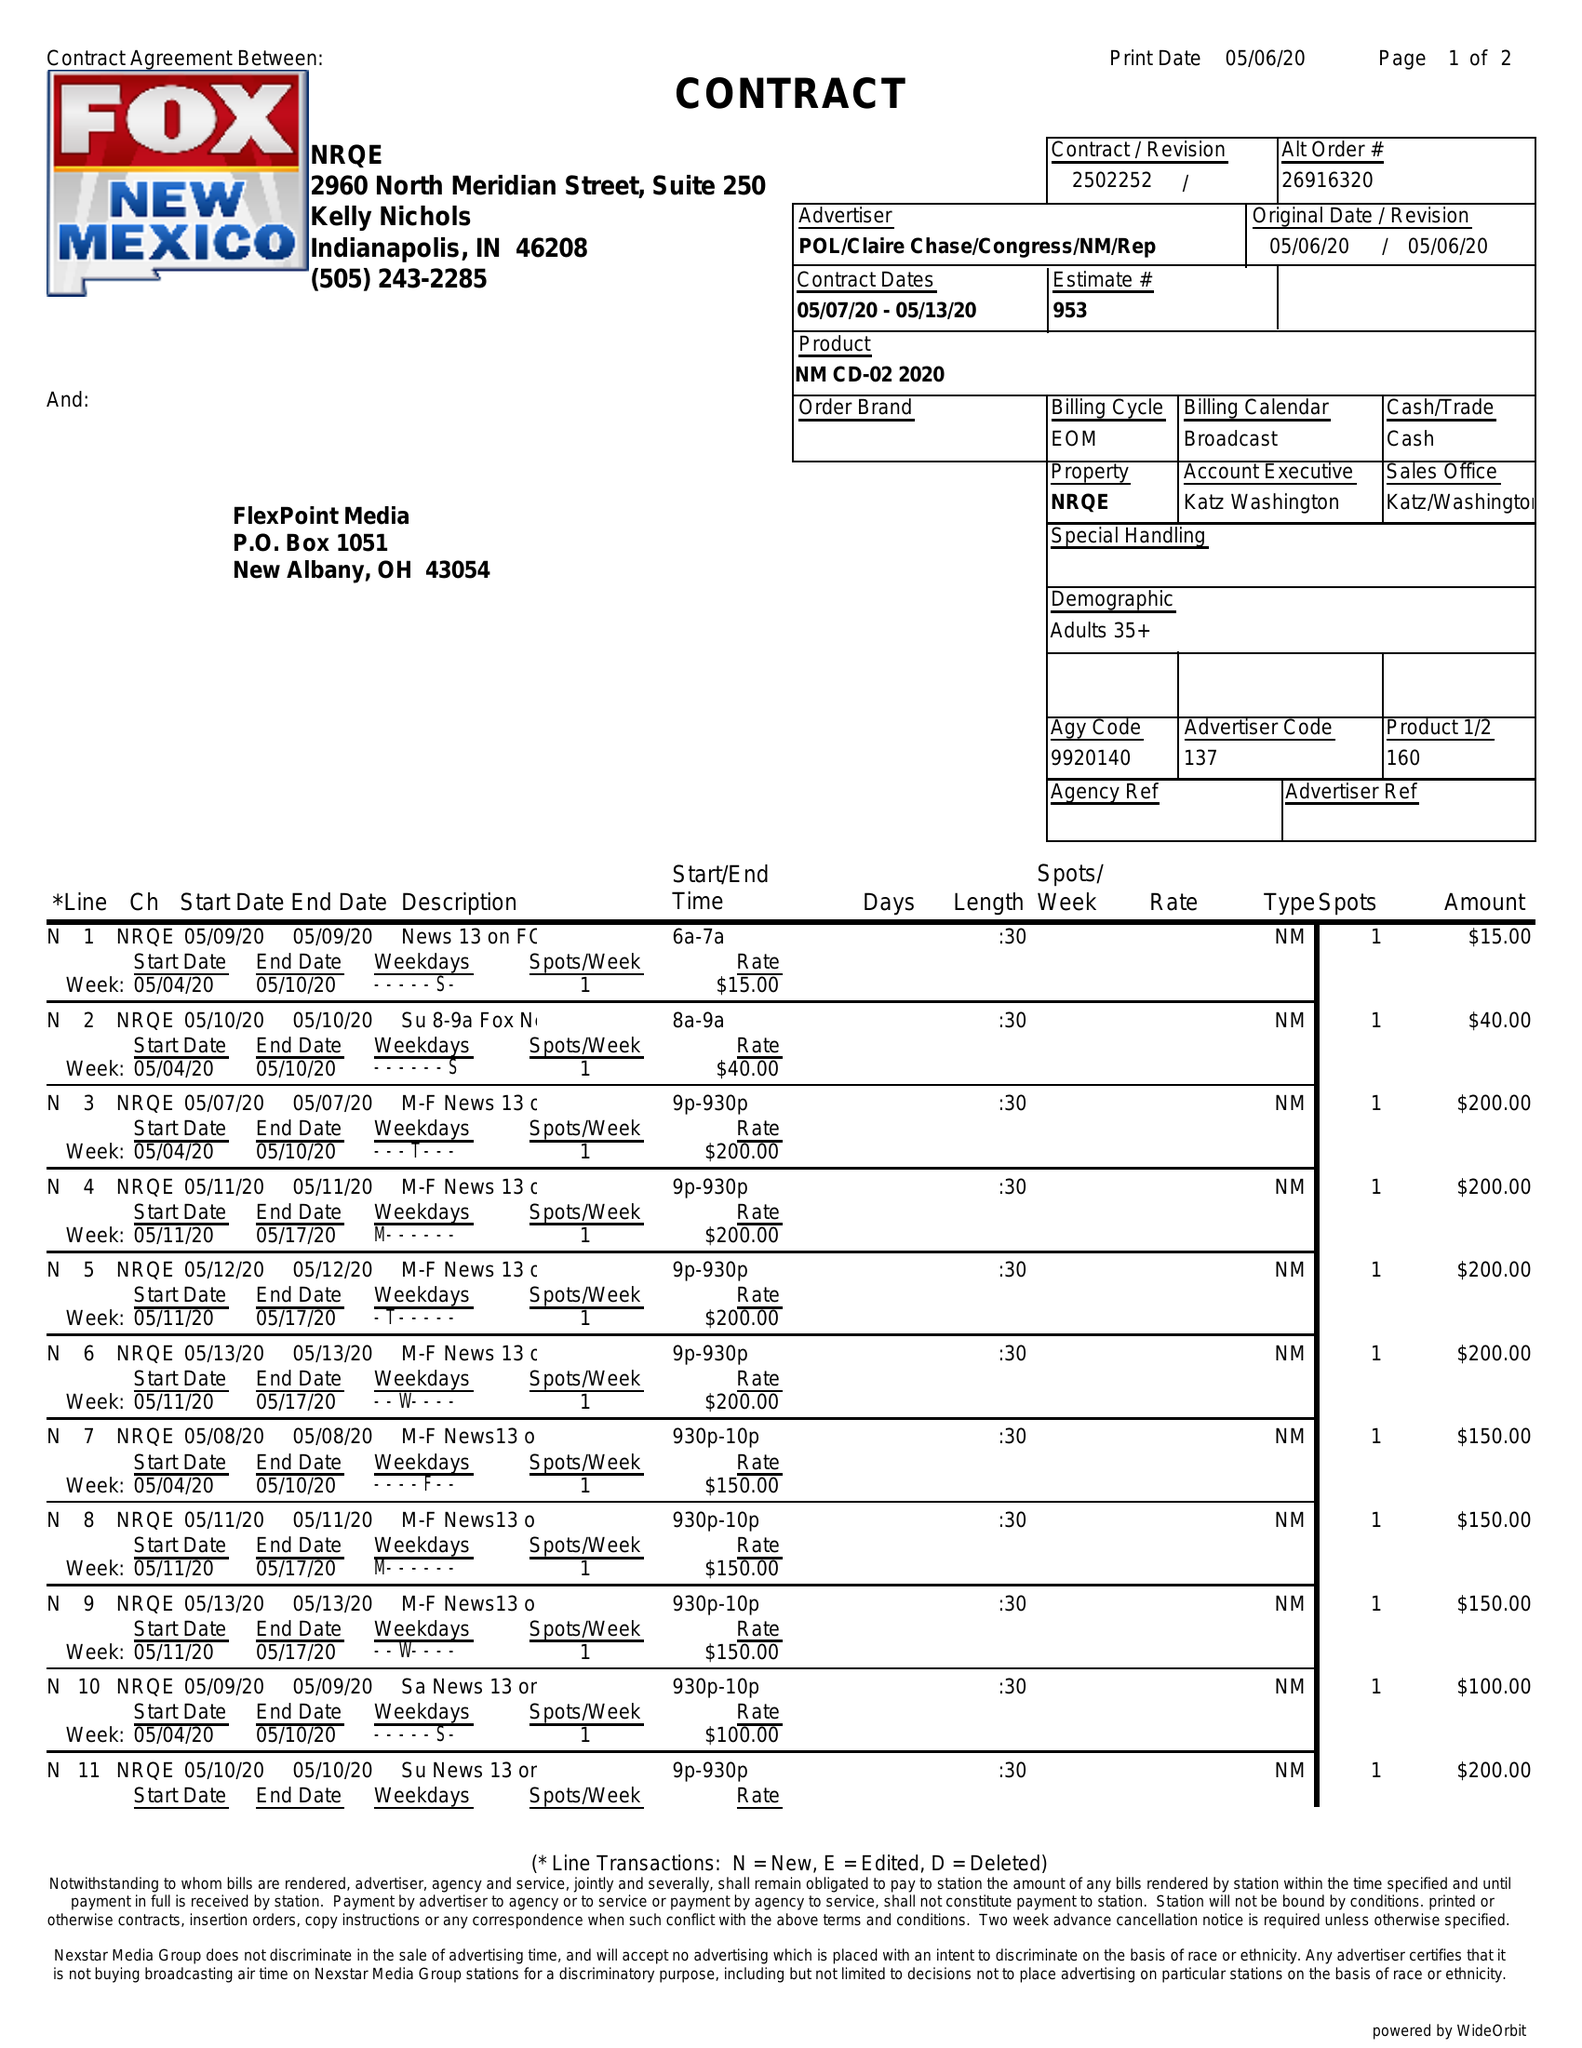What is the value for the advertiser?
Answer the question using a single word or phrase. POL/CLAIRECHASE/CONGRESS/NM/REP 